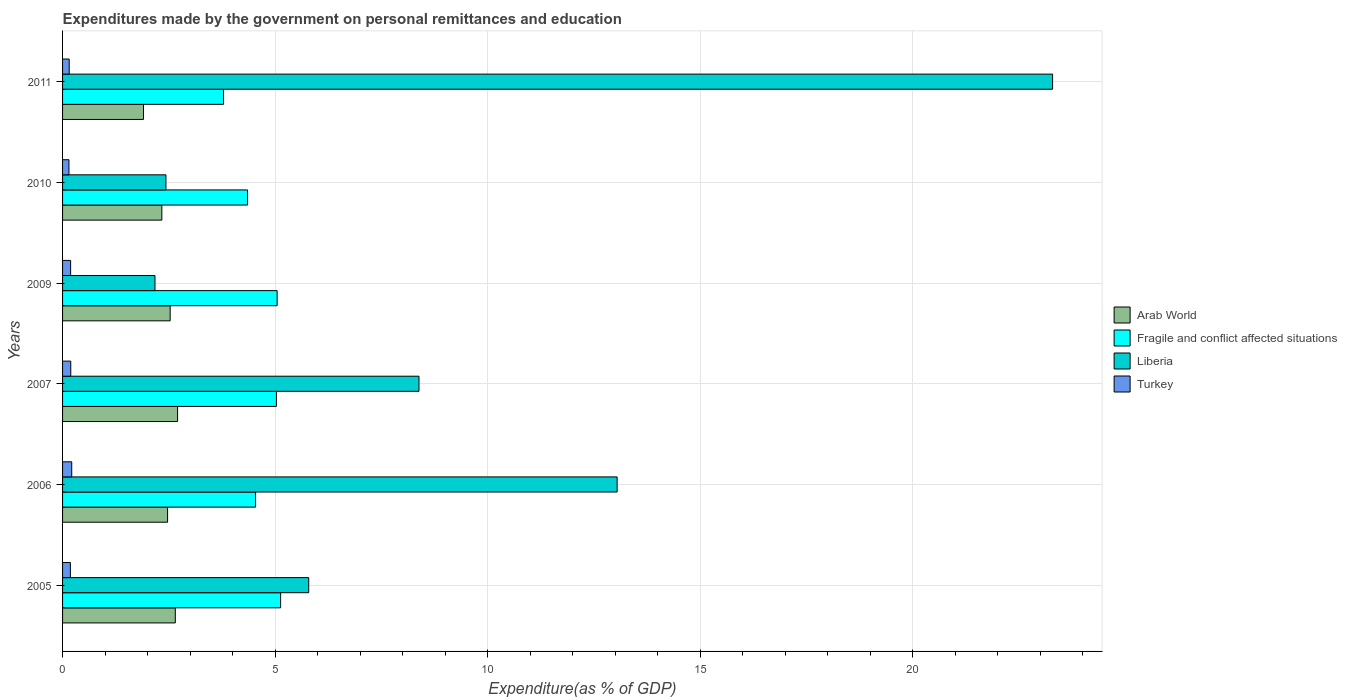How many different coloured bars are there?
Your answer should be compact. 4. How many groups of bars are there?
Your answer should be compact. 6. Are the number of bars on each tick of the Y-axis equal?
Offer a terse response. Yes. What is the expenditures made by the government on personal remittances and education in Fragile and conflict affected situations in 2010?
Your answer should be very brief. 4.35. Across all years, what is the maximum expenditures made by the government on personal remittances and education in Arab World?
Ensure brevity in your answer.  2.71. Across all years, what is the minimum expenditures made by the government on personal remittances and education in Fragile and conflict affected situations?
Offer a terse response. 3.79. In which year was the expenditures made by the government on personal remittances and education in Fragile and conflict affected situations minimum?
Keep it short and to the point. 2011. What is the total expenditures made by the government on personal remittances and education in Fragile and conflict affected situations in the graph?
Give a very brief answer. 27.89. What is the difference between the expenditures made by the government on personal remittances and education in Turkey in 2005 and that in 2009?
Provide a succinct answer. -0.01. What is the difference between the expenditures made by the government on personal remittances and education in Liberia in 2011 and the expenditures made by the government on personal remittances and education in Turkey in 2007?
Your answer should be compact. 23.1. What is the average expenditures made by the government on personal remittances and education in Fragile and conflict affected situations per year?
Provide a short and direct response. 4.65. In the year 2010, what is the difference between the expenditures made by the government on personal remittances and education in Arab World and expenditures made by the government on personal remittances and education in Fragile and conflict affected situations?
Provide a succinct answer. -2.02. In how many years, is the expenditures made by the government on personal remittances and education in Arab World greater than 6 %?
Your answer should be very brief. 0. What is the ratio of the expenditures made by the government on personal remittances and education in Liberia in 2006 to that in 2009?
Your answer should be very brief. 6. Is the expenditures made by the government on personal remittances and education in Turkey in 2009 less than that in 2011?
Keep it short and to the point. No. Is the difference between the expenditures made by the government on personal remittances and education in Arab World in 2006 and 2007 greater than the difference between the expenditures made by the government on personal remittances and education in Fragile and conflict affected situations in 2006 and 2007?
Your response must be concise. Yes. What is the difference between the highest and the second highest expenditures made by the government on personal remittances and education in Fragile and conflict affected situations?
Give a very brief answer. 0.08. What is the difference between the highest and the lowest expenditures made by the government on personal remittances and education in Turkey?
Ensure brevity in your answer.  0.07. In how many years, is the expenditures made by the government on personal remittances and education in Arab World greater than the average expenditures made by the government on personal remittances and education in Arab World taken over all years?
Give a very brief answer. 4. What does the 1st bar from the top in 2010 represents?
Your answer should be very brief. Turkey. What does the 2nd bar from the bottom in 2011 represents?
Provide a short and direct response. Fragile and conflict affected situations. Are all the bars in the graph horizontal?
Your response must be concise. Yes. What is the difference between two consecutive major ticks on the X-axis?
Your answer should be very brief. 5. Does the graph contain any zero values?
Ensure brevity in your answer.  No. Where does the legend appear in the graph?
Give a very brief answer. Center right. How are the legend labels stacked?
Provide a succinct answer. Vertical. What is the title of the graph?
Give a very brief answer. Expenditures made by the government on personal remittances and education. Does "Comoros" appear as one of the legend labels in the graph?
Offer a terse response. No. What is the label or title of the X-axis?
Ensure brevity in your answer.  Expenditure(as % of GDP). What is the label or title of the Y-axis?
Provide a short and direct response. Years. What is the Expenditure(as % of GDP) of Arab World in 2005?
Ensure brevity in your answer.  2.65. What is the Expenditure(as % of GDP) in Fragile and conflict affected situations in 2005?
Keep it short and to the point. 5.13. What is the Expenditure(as % of GDP) of Liberia in 2005?
Your response must be concise. 5.79. What is the Expenditure(as % of GDP) of Turkey in 2005?
Give a very brief answer. 0.18. What is the Expenditure(as % of GDP) of Arab World in 2006?
Offer a very short reply. 2.47. What is the Expenditure(as % of GDP) in Fragile and conflict affected situations in 2006?
Offer a terse response. 4.54. What is the Expenditure(as % of GDP) in Liberia in 2006?
Offer a very short reply. 13.05. What is the Expenditure(as % of GDP) of Turkey in 2006?
Offer a terse response. 0.22. What is the Expenditure(as % of GDP) in Arab World in 2007?
Ensure brevity in your answer.  2.71. What is the Expenditure(as % of GDP) of Fragile and conflict affected situations in 2007?
Your response must be concise. 5.03. What is the Expenditure(as % of GDP) in Liberia in 2007?
Give a very brief answer. 8.39. What is the Expenditure(as % of GDP) in Turkey in 2007?
Your response must be concise. 0.19. What is the Expenditure(as % of GDP) in Arab World in 2009?
Make the answer very short. 2.53. What is the Expenditure(as % of GDP) in Fragile and conflict affected situations in 2009?
Provide a succinct answer. 5.05. What is the Expenditure(as % of GDP) of Liberia in 2009?
Offer a very short reply. 2.17. What is the Expenditure(as % of GDP) of Turkey in 2009?
Ensure brevity in your answer.  0.19. What is the Expenditure(as % of GDP) of Arab World in 2010?
Give a very brief answer. 2.34. What is the Expenditure(as % of GDP) of Fragile and conflict affected situations in 2010?
Ensure brevity in your answer.  4.35. What is the Expenditure(as % of GDP) of Liberia in 2010?
Offer a terse response. 2.43. What is the Expenditure(as % of GDP) in Turkey in 2010?
Offer a terse response. 0.15. What is the Expenditure(as % of GDP) in Arab World in 2011?
Offer a very short reply. 1.9. What is the Expenditure(as % of GDP) of Fragile and conflict affected situations in 2011?
Provide a short and direct response. 3.79. What is the Expenditure(as % of GDP) of Liberia in 2011?
Give a very brief answer. 23.29. What is the Expenditure(as % of GDP) of Turkey in 2011?
Offer a terse response. 0.16. Across all years, what is the maximum Expenditure(as % of GDP) in Arab World?
Your answer should be compact. 2.71. Across all years, what is the maximum Expenditure(as % of GDP) of Fragile and conflict affected situations?
Your response must be concise. 5.13. Across all years, what is the maximum Expenditure(as % of GDP) in Liberia?
Offer a terse response. 23.29. Across all years, what is the maximum Expenditure(as % of GDP) of Turkey?
Offer a very short reply. 0.22. Across all years, what is the minimum Expenditure(as % of GDP) of Arab World?
Provide a succinct answer. 1.9. Across all years, what is the minimum Expenditure(as % of GDP) in Fragile and conflict affected situations?
Make the answer very short. 3.79. Across all years, what is the minimum Expenditure(as % of GDP) in Liberia?
Ensure brevity in your answer.  2.17. Across all years, what is the minimum Expenditure(as % of GDP) of Turkey?
Provide a succinct answer. 0.15. What is the total Expenditure(as % of GDP) in Arab World in the graph?
Keep it short and to the point. 14.6. What is the total Expenditure(as % of GDP) in Fragile and conflict affected situations in the graph?
Provide a short and direct response. 27.89. What is the total Expenditure(as % of GDP) of Liberia in the graph?
Offer a very short reply. 55.13. What is the total Expenditure(as % of GDP) of Turkey in the graph?
Your answer should be very brief. 1.09. What is the difference between the Expenditure(as % of GDP) of Arab World in 2005 and that in 2006?
Ensure brevity in your answer.  0.18. What is the difference between the Expenditure(as % of GDP) in Fragile and conflict affected situations in 2005 and that in 2006?
Make the answer very short. 0.59. What is the difference between the Expenditure(as % of GDP) in Liberia in 2005 and that in 2006?
Offer a very short reply. -7.26. What is the difference between the Expenditure(as % of GDP) in Turkey in 2005 and that in 2006?
Your response must be concise. -0.03. What is the difference between the Expenditure(as % of GDP) of Arab World in 2005 and that in 2007?
Make the answer very short. -0.05. What is the difference between the Expenditure(as % of GDP) in Fragile and conflict affected situations in 2005 and that in 2007?
Offer a terse response. 0.1. What is the difference between the Expenditure(as % of GDP) of Liberia in 2005 and that in 2007?
Provide a short and direct response. -2.59. What is the difference between the Expenditure(as % of GDP) of Turkey in 2005 and that in 2007?
Make the answer very short. -0.01. What is the difference between the Expenditure(as % of GDP) of Arab World in 2005 and that in 2009?
Ensure brevity in your answer.  0.12. What is the difference between the Expenditure(as % of GDP) of Fragile and conflict affected situations in 2005 and that in 2009?
Make the answer very short. 0.08. What is the difference between the Expenditure(as % of GDP) of Liberia in 2005 and that in 2009?
Ensure brevity in your answer.  3.62. What is the difference between the Expenditure(as % of GDP) of Turkey in 2005 and that in 2009?
Your answer should be very brief. -0.01. What is the difference between the Expenditure(as % of GDP) in Arab World in 2005 and that in 2010?
Ensure brevity in your answer.  0.32. What is the difference between the Expenditure(as % of GDP) in Fragile and conflict affected situations in 2005 and that in 2010?
Your answer should be compact. 0.78. What is the difference between the Expenditure(as % of GDP) of Liberia in 2005 and that in 2010?
Offer a terse response. 3.36. What is the difference between the Expenditure(as % of GDP) of Turkey in 2005 and that in 2010?
Your response must be concise. 0.03. What is the difference between the Expenditure(as % of GDP) of Arab World in 2005 and that in 2011?
Your answer should be very brief. 0.75. What is the difference between the Expenditure(as % of GDP) of Fragile and conflict affected situations in 2005 and that in 2011?
Your answer should be very brief. 1.34. What is the difference between the Expenditure(as % of GDP) of Liberia in 2005 and that in 2011?
Your answer should be compact. -17.5. What is the difference between the Expenditure(as % of GDP) in Turkey in 2005 and that in 2011?
Provide a short and direct response. 0.03. What is the difference between the Expenditure(as % of GDP) in Arab World in 2006 and that in 2007?
Ensure brevity in your answer.  -0.24. What is the difference between the Expenditure(as % of GDP) in Fragile and conflict affected situations in 2006 and that in 2007?
Offer a terse response. -0.49. What is the difference between the Expenditure(as % of GDP) in Liberia in 2006 and that in 2007?
Your answer should be compact. 4.66. What is the difference between the Expenditure(as % of GDP) of Turkey in 2006 and that in 2007?
Provide a succinct answer. 0.02. What is the difference between the Expenditure(as % of GDP) of Arab World in 2006 and that in 2009?
Offer a terse response. -0.06. What is the difference between the Expenditure(as % of GDP) in Fragile and conflict affected situations in 2006 and that in 2009?
Provide a succinct answer. -0.51. What is the difference between the Expenditure(as % of GDP) of Liberia in 2006 and that in 2009?
Keep it short and to the point. 10.87. What is the difference between the Expenditure(as % of GDP) of Turkey in 2006 and that in 2009?
Make the answer very short. 0.03. What is the difference between the Expenditure(as % of GDP) of Arab World in 2006 and that in 2010?
Provide a succinct answer. 0.14. What is the difference between the Expenditure(as % of GDP) in Fragile and conflict affected situations in 2006 and that in 2010?
Your answer should be very brief. 0.19. What is the difference between the Expenditure(as % of GDP) of Liberia in 2006 and that in 2010?
Your answer should be very brief. 10.62. What is the difference between the Expenditure(as % of GDP) of Turkey in 2006 and that in 2010?
Your answer should be compact. 0.07. What is the difference between the Expenditure(as % of GDP) of Arab World in 2006 and that in 2011?
Keep it short and to the point. 0.57. What is the difference between the Expenditure(as % of GDP) of Fragile and conflict affected situations in 2006 and that in 2011?
Your answer should be compact. 0.76. What is the difference between the Expenditure(as % of GDP) in Liberia in 2006 and that in 2011?
Provide a short and direct response. -10.25. What is the difference between the Expenditure(as % of GDP) of Turkey in 2006 and that in 2011?
Your response must be concise. 0.06. What is the difference between the Expenditure(as % of GDP) in Arab World in 2007 and that in 2009?
Your answer should be very brief. 0.17. What is the difference between the Expenditure(as % of GDP) of Fragile and conflict affected situations in 2007 and that in 2009?
Keep it short and to the point. -0.02. What is the difference between the Expenditure(as % of GDP) in Liberia in 2007 and that in 2009?
Your response must be concise. 6.21. What is the difference between the Expenditure(as % of GDP) in Turkey in 2007 and that in 2009?
Give a very brief answer. 0. What is the difference between the Expenditure(as % of GDP) in Arab World in 2007 and that in 2010?
Your answer should be compact. 0.37. What is the difference between the Expenditure(as % of GDP) of Fragile and conflict affected situations in 2007 and that in 2010?
Offer a terse response. 0.68. What is the difference between the Expenditure(as % of GDP) in Liberia in 2007 and that in 2010?
Make the answer very short. 5.95. What is the difference between the Expenditure(as % of GDP) in Turkey in 2007 and that in 2010?
Offer a terse response. 0.04. What is the difference between the Expenditure(as % of GDP) of Arab World in 2007 and that in 2011?
Offer a very short reply. 0.8. What is the difference between the Expenditure(as % of GDP) of Fragile and conflict affected situations in 2007 and that in 2011?
Keep it short and to the point. 1.24. What is the difference between the Expenditure(as % of GDP) in Liberia in 2007 and that in 2011?
Keep it short and to the point. -14.91. What is the difference between the Expenditure(as % of GDP) in Turkey in 2007 and that in 2011?
Your answer should be compact. 0.04. What is the difference between the Expenditure(as % of GDP) of Arab World in 2009 and that in 2010?
Make the answer very short. 0.2. What is the difference between the Expenditure(as % of GDP) of Fragile and conflict affected situations in 2009 and that in 2010?
Make the answer very short. 0.7. What is the difference between the Expenditure(as % of GDP) of Liberia in 2009 and that in 2010?
Your response must be concise. -0.26. What is the difference between the Expenditure(as % of GDP) of Turkey in 2009 and that in 2010?
Your response must be concise. 0.04. What is the difference between the Expenditure(as % of GDP) of Arab World in 2009 and that in 2011?
Provide a succinct answer. 0.63. What is the difference between the Expenditure(as % of GDP) in Fragile and conflict affected situations in 2009 and that in 2011?
Provide a succinct answer. 1.26. What is the difference between the Expenditure(as % of GDP) of Liberia in 2009 and that in 2011?
Your response must be concise. -21.12. What is the difference between the Expenditure(as % of GDP) in Turkey in 2009 and that in 2011?
Your answer should be very brief. 0.03. What is the difference between the Expenditure(as % of GDP) of Arab World in 2010 and that in 2011?
Provide a succinct answer. 0.43. What is the difference between the Expenditure(as % of GDP) of Fragile and conflict affected situations in 2010 and that in 2011?
Your answer should be very brief. 0.57. What is the difference between the Expenditure(as % of GDP) of Liberia in 2010 and that in 2011?
Give a very brief answer. -20.86. What is the difference between the Expenditure(as % of GDP) in Turkey in 2010 and that in 2011?
Offer a very short reply. -0.01. What is the difference between the Expenditure(as % of GDP) in Arab World in 2005 and the Expenditure(as % of GDP) in Fragile and conflict affected situations in 2006?
Your answer should be compact. -1.89. What is the difference between the Expenditure(as % of GDP) in Arab World in 2005 and the Expenditure(as % of GDP) in Liberia in 2006?
Give a very brief answer. -10.4. What is the difference between the Expenditure(as % of GDP) in Arab World in 2005 and the Expenditure(as % of GDP) in Turkey in 2006?
Ensure brevity in your answer.  2.44. What is the difference between the Expenditure(as % of GDP) of Fragile and conflict affected situations in 2005 and the Expenditure(as % of GDP) of Liberia in 2006?
Your answer should be very brief. -7.92. What is the difference between the Expenditure(as % of GDP) in Fragile and conflict affected situations in 2005 and the Expenditure(as % of GDP) in Turkey in 2006?
Your response must be concise. 4.91. What is the difference between the Expenditure(as % of GDP) of Liberia in 2005 and the Expenditure(as % of GDP) of Turkey in 2006?
Make the answer very short. 5.58. What is the difference between the Expenditure(as % of GDP) in Arab World in 2005 and the Expenditure(as % of GDP) in Fragile and conflict affected situations in 2007?
Ensure brevity in your answer.  -2.38. What is the difference between the Expenditure(as % of GDP) in Arab World in 2005 and the Expenditure(as % of GDP) in Liberia in 2007?
Your answer should be compact. -5.73. What is the difference between the Expenditure(as % of GDP) of Arab World in 2005 and the Expenditure(as % of GDP) of Turkey in 2007?
Offer a terse response. 2.46. What is the difference between the Expenditure(as % of GDP) in Fragile and conflict affected situations in 2005 and the Expenditure(as % of GDP) in Liberia in 2007?
Provide a succinct answer. -3.26. What is the difference between the Expenditure(as % of GDP) in Fragile and conflict affected situations in 2005 and the Expenditure(as % of GDP) in Turkey in 2007?
Your answer should be very brief. 4.94. What is the difference between the Expenditure(as % of GDP) of Liberia in 2005 and the Expenditure(as % of GDP) of Turkey in 2007?
Keep it short and to the point. 5.6. What is the difference between the Expenditure(as % of GDP) in Arab World in 2005 and the Expenditure(as % of GDP) in Fragile and conflict affected situations in 2009?
Keep it short and to the point. -2.4. What is the difference between the Expenditure(as % of GDP) in Arab World in 2005 and the Expenditure(as % of GDP) in Liberia in 2009?
Ensure brevity in your answer.  0.48. What is the difference between the Expenditure(as % of GDP) of Arab World in 2005 and the Expenditure(as % of GDP) of Turkey in 2009?
Offer a terse response. 2.46. What is the difference between the Expenditure(as % of GDP) in Fragile and conflict affected situations in 2005 and the Expenditure(as % of GDP) in Liberia in 2009?
Ensure brevity in your answer.  2.96. What is the difference between the Expenditure(as % of GDP) of Fragile and conflict affected situations in 2005 and the Expenditure(as % of GDP) of Turkey in 2009?
Offer a terse response. 4.94. What is the difference between the Expenditure(as % of GDP) in Liberia in 2005 and the Expenditure(as % of GDP) in Turkey in 2009?
Provide a short and direct response. 5.6. What is the difference between the Expenditure(as % of GDP) of Arab World in 2005 and the Expenditure(as % of GDP) of Fragile and conflict affected situations in 2010?
Give a very brief answer. -1.7. What is the difference between the Expenditure(as % of GDP) in Arab World in 2005 and the Expenditure(as % of GDP) in Liberia in 2010?
Your answer should be compact. 0.22. What is the difference between the Expenditure(as % of GDP) in Arab World in 2005 and the Expenditure(as % of GDP) in Turkey in 2010?
Your answer should be very brief. 2.5. What is the difference between the Expenditure(as % of GDP) in Fragile and conflict affected situations in 2005 and the Expenditure(as % of GDP) in Liberia in 2010?
Make the answer very short. 2.7. What is the difference between the Expenditure(as % of GDP) of Fragile and conflict affected situations in 2005 and the Expenditure(as % of GDP) of Turkey in 2010?
Your response must be concise. 4.98. What is the difference between the Expenditure(as % of GDP) in Liberia in 2005 and the Expenditure(as % of GDP) in Turkey in 2010?
Give a very brief answer. 5.64. What is the difference between the Expenditure(as % of GDP) in Arab World in 2005 and the Expenditure(as % of GDP) in Fragile and conflict affected situations in 2011?
Offer a terse response. -1.13. What is the difference between the Expenditure(as % of GDP) of Arab World in 2005 and the Expenditure(as % of GDP) of Liberia in 2011?
Provide a succinct answer. -20.64. What is the difference between the Expenditure(as % of GDP) in Arab World in 2005 and the Expenditure(as % of GDP) in Turkey in 2011?
Your answer should be compact. 2.5. What is the difference between the Expenditure(as % of GDP) in Fragile and conflict affected situations in 2005 and the Expenditure(as % of GDP) in Liberia in 2011?
Your answer should be very brief. -18.16. What is the difference between the Expenditure(as % of GDP) in Fragile and conflict affected situations in 2005 and the Expenditure(as % of GDP) in Turkey in 2011?
Your answer should be very brief. 4.97. What is the difference between the Expenditure(as % of GDP) of Liberia in 2005 and the Expenditure(as % of GDP) of Turkey in 2011?
Offer a very short reply. 5.64. What is the difference between the Expenditure(as % of GDP) in Arab World in 2006 and the Expenditure(as % of GDP) in Fragile and conflict affected situations in 2007?
Make the answer very short. -2.56. What is the difference between the Expenditure(as % of GDP) of Arab World in 2006 and the Expenditure(as % of GDP) of Liberia in 2007?
Provide a short and direct response. -5.92. What is the difference between the Expenditure(as % of GDP) of Arab World in 2006 and the Expenditure(as % of GDP) of Turkey in 2007?
Ensure brevity in your answer.  2.28. What is the difference between the Expenditure(as % of GDP) in Fragile and conflict affected situations in 2006 and the Expenditure(as % of GDP) in Liberia in 2007?
Keep it short and to the point. -3.84. What is the difference between the Expenditure(as % of GDP) of Fragile and conflict affected situations in 2006 and the Expenditure(as % of GDP) of Turkey in 2007?
Your response must be concise. 4.35. What is the difference between the Expenditure(as % of GDP) in Liberia in 2006 and the Expenditure(as % of GDP) in Turkey in 2007?
Offer a very short reply. 12.86. What is the difference between the Expenditure(as % of GDP) in Arab World in 2006 and the Expenditure(as % of GDP) in Fragile and conflict affected situations in 2009?
Provide a short and direct response. -2.58. What is the difference between the Expenditure(as % of GDP) in Arab World in 2006 and the Expenditure(as % of GDP) in Liberia in 2009?
Make the answer very short. 0.3. What is the difference between the Expenditure(as % of GDP) of Arab World in 2006 and the Expenditure(as % of GDP) of Turkey in 2009?
Your answer should be very brief. 2.28. What is the difference between the Expenditure(as % of GDP) of Fragile and conflict affected situations in 2006 and the Expenditure(as % of GDP) of Liberia in 2009?
Your answer should be very brief. 2.37. What is the difference between the Expenditure(as % of GDP) in Fragile and conflict affected situations in 2006 and the Expenditure(as % of GDP) in Turkey in 2009?
Your answer should be very brief. 4.35. What is the difference between the Expenditure(as % of GDP) in Liberia in 2006 and the Expenditure(as % of GDP) in Turkey in 2009?
Your answer should be compact. 12.86. What is the difference between the Expenditure(as % of GDP) in Arab World in 2006 and the Expenditure(as % of GDP) in Fragile and conflict affected situations in 2010?
Provide a succinct answer. -1.88. What is the difference between the Expenditure(as % of GDP) of Arab World in 2006 and the Expenditure(as % of GDP) of Liberia in 2010?
Provide a succinct answer. 0.04. What is the difference between the Expenditure(as % of GDP) in Arab World in 2006 and the Expenditure(as % of GDP) in Turkey in 2010?
Provide a succinct answer. 2.32. What is the difference between the Expenditure(as % of GDP) in Fragile and conflict affected situations in 2006 and the Expenditure(as % of GDP) in Liberia in 2010?
Keep it short and to the point. 2.11. What is the difference between the Expenditure(as % of GDP) in Fragile and conflict affected situations in 2006 and the Expenditure(as % of GDP) in Turkey in 2010?
Your response must be concise. 4.39. What is the difference between the Expenditure(as % of GDP) in Liberia in 2006 and the Expenditure(as % of GDP) in Turkey in 2010?
Offer a terse response. 12.9. What is the difference between the Expenditure(as % of GDP) of Arab World in 2006 and the Expenditure(as % of GDP) of Fragile and conflict affected situations in 2011?
Offer a terse response. -1.32. What is the difference between the Expenditure(as % of GDP) in Arab World in 2006 and the Expenditure(as % of GDP) in Liberia in 2011?
Keep it short and to the point. -20.82. What is the difference between the Expenditure(as % of GDP) of Arab World in 2006 and the Expenditure(as % of GDP) of Turkey in 2011?
Your answer should be compact. 2.31. What is the difference between the Expenditure(as % of GDP) in Fragile and conflict affected situations in 2006 and the Expenditure(as % of GDP) in Liberia in 2011?
Keep it short and to the point. -18.75. What is the difference between the Expenditure(as % of GDP) of Fragile and conflict affected situations in 2006 and the Expenditure(as % of GDP) of Turkey in 2011?
Keep it short and to the point. 4.39. What is the difference between the Expenditure(as % of GDP) in Liberia in 2006 and the Expenditure(as % of GDP) in Turkey in 2011?
Your answer should be very brief. 12.89. What is the difference between the Expenditure(as % of GDP) of Arab World in 2007 and the Expenditure(as % of GDP) of Fragile and conflict affected situations in 2009?
Keep it short and to the point. -2.34. What is the difference between the Expenditure(as % of GDP) of Arab World in 2007 and the Expenditure(as % of GDP) of Liberia in 2009?
Provide a short and direct response. 0.53. What is the difference between the Expenditure(as % of GDP) of Arab World in 2007 and the Expenditure(as % of GDP) of Turkey in 2009?
Provide a succinct answer. 2.52. What is the difference between the Expenditure(as % of GDP) in Fragile and conflict affected situations in 2007 and the Expenditure(as % of GDP) in Liberia in 2009?
Provide a succinct answer. 2.86. What is the difference between the Expenditure(as % of GDP) in Fragile and conflict affected situations in 2007 and the Expenditure(as % of GDP) in Turkey in 2009?
Give a very brief answer. 4.84. What is the difference between the Expenditure(as % of GDP) of Liberia in 2007 and the Expenditure(as % of GDP) of Turkey in 2009?
Provide a succinct answer. 8.2. What is the difference between the Expenditure(as % of GDP) in Arab World in 2007 and the Expenditure(as % of GDP) in Fragile and conflict affected situations in 2010?
Your answer should be very brief. -1.65. What is the difference between the Expenditure(as % of GDP) in Arab World in 2007 and the Expenditure(as % of GDP) in Liberia in 2010?
Provide a short and direct response. 0.27. What is the difference between the Expenditure(as % of GDP) in Arab World in 2007 and the Expenditure(as % of GDP) in Turkey in 2010?
Make the answer very short. 2.56. What is the difference between the Expenditure(as % of GDP) in Fragile and conflict affected situations in 2007 and the Expenditure(as % of GDP) in Liberia in 2010?
Your response must be concise. 2.6. What is the difference between the Expenditure(as % of GDP) of Fragile and conflict affected situations in 2007 and the Expenditure(as % of GDP) of Turkey in 2010?
Make the answer very short. 4.88. What is the difference between the Expenditure(as % of GDP) in Liberia in 2007 and the Expenditure(as % of GDP) in Turkey in 2010?
Your response must be concise. 8.24. What is the difference between the Expenditure(as % of GDP) in Arab World in 2007 and the Expenditure(as % of GDP) in Fragile and conflict affected situations in 2011?
Give a very brief answer. -1.08. What is the difference between the Expenditure(as % of GDP) of Arab World in 2007 and the Expenditure(as % of GDP) of Liberia in 2011?
Offer a very short reply. -20.59. What is the difference between the Expenditure(as % of GDP) in Arab World in 2007 and the Expenditure(as % of GDP) in Turkey in 2011?
Provide a short and direct response. 2.55. What is the difference between the Expenditure(as % of GDP) of Fragile and conflict affected situations in 2007 and the Expenditure(as % of GDP) of Liberia in 2011?
Give a very brief answer. -18.26. What is the difference between the Expenditure(as % of GDP) of Fragile and conflict affected situations in 2007 and the Expenditure(as % of GDP) of Turkey in 2011?
Offer a terse response. 4.88. What is the difference between the Expenditure(as % of GDP) of Liberia in 2007 and the Expenditure(as % of GDP) of Turkey in 2011?
Your answer should be very brief. 8.23. What is the difference between the Expenditure(as % of GDP) in Arab World in 2009 and the Expenditure(as % of GDP) in Fragile and conflict affected situations in 2010?
Make the answer very short. -1.82. What is the difference between the Expenditure(as % of GDP) in Arab World in 2009 and the Expenditure(as % of GDP) in Liberia in 2010?
Ensure brevity in your answer.  0.1. What is the difference between the Expenditure(as % of GDP) of Arab World in 2009 and the Expenditure(as % of GDP) of Turkey in 2010?
Make the answer very short. 2.38. What is the difference between the Expenditure(as % of GDP) in Fragile and conflict affected situations in 2009 and the Expenditure(as % of GDP) in Liberia in 2010?
Your answer should be very brief. 2.62. What is the difference between the Expenditure(as % of GDP) of Fragile and conflict affected situations in 2009 and the Expenditure(as % of GDP) of Turkey in 2010?
Make the answer very short. 4.9. What is the difference between the Expenditure(as % of GDP) of Liberia in 2009 and the Expenditure(as % of GDP) of Turkey in 2010?
Give a very brief answer. 2.02. What is the difference between the Expenditure(as % of GDP) of Arab World in 2009 and the Expenditure(as % of GDP) of Fragile and conflict affected situations in 2011?
Offer a terse response. -1.26. What is the difference between the Expenditure(as % of GDP) in Arab World in 2009 and the Expenditure(as % of GDP) in Liberia in 2011?
Your response must be concise. -20.76. What is the difference between the Expenditure(as % of GDP) of Arab World in 2009 and the Expenditure(as % of GDP) of Turkey in 2011?
Your answer should be very brief. 2.38. What is the difference between the Expenditure(as % of GDP) of Fragile and conflict affected situations in 2009 and the Expenditure(as % of GDP) of Liberia in 2011?
Your response must be concise. -18.25. What is the difference between the Expenditure(as % of GDP) in Fragile and conflict affected situations in 2009 and the Expenditure(as % of GDP) in Turkey in 2011?
Provide a short and direct response. 4.89. What is the difference between the Expenditure(as % of GDP) in Liberia in 2009 and the Expenditure(as % of GDP) in Turkey in 2011?
Provide a succinct answer. 2.02. What is the difference between the Expenditure(as % of GDP) of Arab World in 2010 and the Expenditure(as % of GDP) of Fragile and conflict affected situations in 2011?
Keep it short and to the point. -1.45. What is the difference between the Expenditure(as % of GDP) in Arab World in 2010 and the Expenditure(as % of GDP) in Liberia in 2011?
Offer a very short reply. -20.96. What is the difference between the Expenditure(as % of GDP) in Arab World in 2010 and the Expenditure(as % of GDP) in Turkey in 2011?
Your answer should be very brief. 2.18. What is the difference between the Expenditure(as % of GDP) of Fragile and conflict affected situations in 2010 and the Expenditure(as % of GDP) of Liberia in 2011?
Provide a short and direct response. -18.94. What is the difference between the Expenditure(as % of GDP) in Fragile and conflict affected situations in 2010 and the Expenditure(as % of GDP) in Turkey in 2011?
Offer a terse response. 4.2. What is the difference between the Expenditure(as % of GDP) in Liberia in 2010 and the Expenditure(as % of GDP) in Turkey in 2011?
Make the answer very short. 2.28. What is the average Expenditure(as % of GDP) of Arab World per year?
Your response must be concise. 2.43. What is the average Expenditure(as % of GDP) in Fragile and conflict affected situations per year?
Offer a terse response. 4.65. What is the average Expenditure(as % of GDP) in Liberia per year?
Offer a terse response. 9.19. What is the average Expenditure(as % of GDP) of Turkey per year?
Your response must be concise. 0.18. In the year 2005, what is the difference between the Expenditure(as % of GDP) in Arab World and Expenditure(as % of GDP) in Fragile and conflict affected situations?
Your answer should be very brief. -2.48. In the year 2005, what is the difference between the Expenditure(as % of GDP) in Arab World and Expenditure(as % of GDP) in Liberia?
Offer a very short reply. -3.14. In the year 2005, what is the difference between the Expenditure(as % of GDP) in Arab World and Expenditure(as % of GDP) in Turkey?
Your answer should be very brief. 2.47. In the year 2005, what is the difference between the Expenditure(as % of GDP) in Fragile and conflict affected situations and Expenditure(as % of GDP) in Liberia?
Provide a short and direct response. -0.66. In the year 2005, what is the difference between the Expenditure(as % of GDP) of Fragile and conflict affected situations and Expenditure(as % of GDP) of Turkey?
Keep it short and to the point. 4.95. In the year 2005, what is the difference between the Expenditure(as % of GDP) of Liberia and Expenditure(as % of GDP) of Turkey?
Ensure brevity in your answer.  5.61. In the year 2006, what is the difference between the Expenditure(as % of GDP) in Arab World and Expenditure(as % of GDP) in Fragile and conflict affected situations?
Ensure brevity in your answer.  -2.07. In the year 2006, what is the difference between the Expenditure(as % of GDP) of Arab World and Expenditure(as % of GDP) of Liberia?
Your response must be concise. -10.58. In the year 2006, what is the difference between the Expenditure(as % of GDP) of Arab World and Expenditure(as % of GDP) of Turkey?
Make the answer very short. 2.25. In the year 2006, what is the difference between the Expenditure(as % of GDP) of Fragile and conflict affected situations and Expenditure(as % of GDP) of Liberia?
Keep it short and to the point. -8.51. In the year 2006, what is the difference between the Expenditure(as % of GDP) of Fragile and conflict affected situations and Expenditure(as % of GDP) of Turkey?
Your answer should be very brief. 4.33. In the year 2006, what is the difference between the Expenditure(as % of GDP) in Liberia and Expenditure(as % of GDP) in Turkey?
Offer a terse response. 12.83. In the year 2007, what is the difference between the Expenditure(as % of GDP) in Arab World and Expenditure(as % of GDP) in Fragile and conflict affected situations?
Make the answer very short. -2.33. In the year 2007, what is the difference between the Expenditure(as % of GDP) of Arab World and Expenditure(as % of GDP) of Liberia?
Keep it short and to the point. -5.68. In the year 2007, what is the difference between the Expenditure(as % of GDP) in Arab World and Expenditure(as % of GDP) in Turkey?
Offer a terse response. 2.51. In the year 2007, what is the difference between the Expenditure(as % of GDP) of Fragile and conflict affected situations and Expenditure(as % of GDP) of Liberia?
Provide a short and direct response. -3.35. In the year 2007, what is the difference between the Expenditure(as % of GDP) of Fragile and conflict affected situations and Expenditure(as % of GDP) of Turkey?
Give a very brief answer. 4.84. In the year 2007, what is the difference between the Expenditure(as % of GDP) in Liberia and Expenditure(as % of GDP) in Turkey?
Make the answer very short. 8.19. In the year 2009, what is the difference between the Expenditure(as % of GDP) in Arab World and Expenditure(as % of GDP) in Fragile and conflict affected situations?
Your answer should be compact. -2.52. In the year 2009, what is the difference between the Expenditure(as % of GDP) of Arab World and Expenditure(as % of GDP) of Liberia?
Your answer should be compact. 0.36. In the year 2009, what is the difference between the Expenditure(as % of GDP) of Arab World and Expenditure(as % of GDP) of Turkey?
Ensure brevity in your answer.  2.34. In the year 2009, what is the difference between the Expenditure(as % of GDP) of Fragile and conflict affected situations and Expenditure(as % of GDP) of Liberia?
Offer a terse response. 2.87. In the year 2009, what is the difference between the Expenditure(as % of GDP) of Fragile and conflict affected situations and Expenditure(as % of GDP) of Turkey?
Your answer should be compact. 4.86. In the year 2009, what is the difference between the Expenditure(as % of GDP) of Liberia and Expenditure(as % of GDP) of Turkey?
Keep it short and to the point. 1.98. In the year 2010, what is the difference between the Expenditure(as % of GDP) of Arab World and Expenditure(as % of GDP) of Fragile and conflict affected situations?
Your answer should be compact. -2.02. In the year 2010, what is the difference between the Expenditure(as % of GDP) in Arab World and Expenditure(as % of GDP) in Liberia?
Make the answer very short. -0.1. In the year 2010, what is the difference between the Expenditure(as % of GDP) in Arab World and Expenditure(as % of GDP) in Turkey?
Keep it short and to the point. 2.19. In the year 2010, what is the difference between the Expenditure(as % of GDP) of Fragile and conflict affected situations and Expenditure(as % of GDP) of Liberia?
Make the answer very short. 1.92. In the year 2010, what is the difference between the Expenditure(as % of GDP) of Fragile and conflict affected situations and Expenditure(as % of GDP) of Turkey?
Offer a very short reply. 4.2. In the year 2010, what is the difference between the Expenditure(as % of GDP) in Liberia and Expenditure(as % of GDP) in Turkey?
Your response must be concise. 2.28. In the year 2011, what is the difference between the Expenditure(as % of GDP) of Arab World and Expenditure(as % of GDP) of Fragile and conflict affected situations?
Offer a very short reply. -1.88. In the year 2011, what is the difference between the Expenditure(as % of GDP) of Arab World and Expenditure(as % of GDP) of Liberia?
Your answer should be compact. -21.39. In the year 2011, what is the difference between the Expenditure(as % of GDP) in Arab World and Expenditure(as % of GDP) in Turkey?
Keep it short and to the point. 1.75. In the year 2011, what is the difference between the Expenditure(as % of GDP) in Fragile and conflict affected situations and Expenditure(as % of GDP) in Liberia?
Keep it short and to the point. -19.51. In the year 2011, what is the difference between the Expenditure(as % of GDP) of Fragile and conflict affected situations and Expenditure(as % of GDP) of Turkey?
Provide a succinct answer. 3.63. In the year 2011, what is the difference between the Expenditure(as % of GDP) of Liberia and Expenditure(as % of GDP) of Turkey?
Your answer should be compact. 23.14. What is the ratio of the Expenditure(as % of GDP) in Arab World in 2005 to that in 2006?
Keep it short and to the point. 1.07. What is the ratio of the Expenditure(as % of GDP) of Fragile and conflict affected situations in 2005 to that in 2006?
Make the answer very short. 1.13. What is the ratio of the Expenditure(as % of GDP) of Liberia in 2005 to that in 2006?
Make the answer very short. 0.44. What is the ratio of the Expenditure(as % of GDP) in Turkey in 2005 to that in 2006?
Your answer should be very brief. 0.85. What is the ratio of the Expenditure(as % of GDP) of Arab World in 2005 to that in 2007?
Keep it short and to the point. 0.98. What is the ratio of the Expenditure(as % of GDP) in Fragile and conflict affected situations in 2005 to that in 2007?
Offer a terse response. 1.02. What is the ratio of the Expenditure(as % of GDP) of Liberia in 2005 to that in 2007?
Offer a terse response. 0.69. What is the ratio of the Expenditure(as % of GDP) of Turkey in 2005 to that in 2007?
Provide a short and direct response. 0.95. What is the ratio of the Expenditure(as % of GDP) of Arab World in 2005 to that in 2009?
Offer a terse response. 1.05. What is the ratio of the Expenditure(as % of GDP) of Fragile and conflict affected situations in 2005 to that in 2009?
Provide a short and direct response. 1.02. What is the ratio of the Expenditure(as % of GDP) of Liberia in 2005 to that in 2009?
Offer a terse response. 2.66. What is the ratio of the Expenditure(as % of GDP) in Turkey in 2005 to that in 2009?
Offer a terse response. 0.97. What is the ratio of the Expenditure(as % of GDP) of Arab World in 2005 to that in 2010?
Keep it short and to the point. 1.14. What is the ratio of the Expenditure(as % of GDP) of Fragile and conflict affected situations in 2005 to that in 2010?
Keep it short and to the point. 1.18. What is the ratio of the Expenditure(as % of GDP) of Liberia in 2005 to that in 2010?
Offer a terse response. 2.38. What is the ratio of the Expenditure(as % of GDP) in Turkey in 2005 to that in 2010?
Ensure brevity in your answer.  1.22. What is the ratio of the Expenditure(as % of GDP) of Arab World in 2005 to that in 2011?
Ensure brevity in your answer.  1.39. What is the ratio of the Expenditure(as % of GDP) in Fragile and conflict affected situations in 2005 to that in 2011?
Give a very brief answer. 1.35. What is the ratio of the Expenditure(as % of GDP) of Liberia in 2005 to that in 2011?
Ensure brevity in your answer.  0.25. What is the ratio of the Expenditure(as % of GDP) of Turkey in 2005 to that in 2011?
Keep it short and to the point. 1.18. What is the ratio of the Expenditure(as % of GDP) in Arab World in 2006 to that in 2007?
Your answer should be very brief. 0.91. What is the ratio of the Expenditure(as % of GDP) of Fragile and conflict affected situations in 2006 to that in 2007?
Your answer should be compact. 0.9. What is the ratio of the Expenditure(as % of GDP) in Liberia in 2006 to that in 2007?
Keep it short and to the point. 1.56. What is the ratio of the Expenditure(as % of GDP) of Turkey in 2006 to that in 2007?
Provide a succinct answer. 1.12. What is the ratio of the Expenditure(as % of GDP) of Arab World in 2006 to that in 2009?
Keep it short and to the point. 0.98. What is the ratio of the Expenditure(as % of GDP) in Fragile and conflict affected situations in 2006 to that in 2009?
Make the answer very short. 0.9. What is the ratio of the Expenditure(as % of GDP) in Liberia in 2006 to that in 2009?
Provide a short and direct response. 6. What is the ratio of the Expenditure(as % of GDP) in Turkey in 2006 to that in 2009?
Provide a short and direct response. 1.14. What is the ratio of the Expenditure(as % of GDP) of Arab World in 2006 to that in 2010?
Provide a succinct answer. 1.06. What is the ratio of the Expenditure(as % of GDP) of Fragile and conflict affected situations in 2006 to that in 2010?
Offer a terse response. 1.04. What is the ratio of the Expenditure(as % of GDP) in Liberia in 2006 to that in 2010?
Give a very brief answer. 5.36. What is the ratio of the Expenditure(as % of GDP) of Turkey in 2006 to that in 2010?
Keep it short and to the point. 1.43. What is the ratio of the Expenditure(as % of GDP) of Arab World in 2006 to that in 2011?
Ensure brevity in your answer.  1.3. What is the ratio of the Expenditure(as % of GDP) of Fragile and conflict affected situations in 2006 to that in 2011?
Make the answer very short. 1.2. What is the ratio of the Expenditure(as % of GDP) of Liberia in 2006 to that in 2011?
Provide a short and direct response. 0.56. What is the ratio of the Expenditure(as % of GDP) of Turkey in 2006 to that in 2011?
Your response must be concise. 1.38. What is the ratio of the Expenditure(as % of GDP) of Arab World in 2007 to that in 2009?
Your response must be concise. 1.07. What is the ratio of the Expenditure(as % of GDP) in Liberia in 2007 to that in 2009?
Offer a terse response. 3.86. What is the ratio of the Expenditure(as % of GDP) of Turkey in 2007 to that in 2009?
Your response must be concise. 1.02. What is the ratio of the Expenditure(as % of GDP) in Arab World in 2007 to that in 2010?
Offer a terse response. 1.16. What is the ratio of the Expenditure(as % of GDP) in Fragile and conflict affected situations in 2007 to that in 2010?
Provide a short and direct response. 1.16. What is the ratio of the Expenditure(as % of GDP) of Liberia in 2007 to that in 2010?
Your answer should be very brief. 3.45. What is the ratio of the Expenditure(as % of GDP) in Turkey in 2007 to that in 2010?
Give a very brief answer. 1.28. What is the ratio of the Expenditure(as % of GDP) in Arab World in 2007 to that in 2011?
Provide a succinct answer. 1.42. What is the ratio of the Expenditure(as % of GDP) in Fragile and conflict affected situations in 2007 to that in 2011?
Keep it short and to the point. 1.33. What is the ratio of the Expenditure(as % of GDP) in Liberia in 2007 to that in 2011?
Make the answer very short. 0.36. What is the ratio of the Expenditure(as % of GDP) in Turkey in 2007 to that in 2011?
Give a very brief answer. 1.23. What is the ratio of the Expenditure(as % of GDP) in Arab World in 2009 to that in 2010?
Your response must be concise. 1.08. What is the ratio of the Expenditure(as % of GDP) in Fragile and conflict affected situations in 2009 to that in 2010?
Give a very brief answer. 1.16. What is the ratio of the Expenditure(as % of GDP) of Liberia in 2009 to that in 2010?
Offer a very short reply. 0.89. What is the ratio of the Expenditure(as % of GDP) of Turkey in 2009 to that in 2010?
Offer a terse response. 1.26. What is the ratio of the Expenditure(as % of GDP) of Arab World in 2009 to that in 2011?
Keep it short and to the point. 1.33. What is the ratio of the Expenditure(as % of GDP) of Fragile and conflict affected situations in 2009 to that in 2011?
Your answer should be compact. 1.33. What is the ratio of the Expenditure(as % of GDP) in Liberia in 2009 to that in 2011?
Give a very brief answer. 0.09. What is the ratio of the Expenditure(as % of GDP) in Turkey in 2009 to that in 2011?
Provide a short and direct response. 1.21. What is the ratio of the Expenditure(as % of GDP) in Arab World in 2010 to that in 2011?
Keep it short and to the point. 1.23. What is the ratio of the Expenditure(as % of GDP) in Fragile and conflict affected situations in 2010 to that in 2011?
Offer a very short reply. 1.15. What is the ratio of the Expenditure(as % of GDP) in Liberia in 2010 to that in 2011?
Your answer should be very brief. 0.1. What is the ratio of the Expenditure(as % of GDP) in Turkey in 2010 to that in 2011?
Keep it short and to the point. 0.96. What is the difference between the highest and the second highest Expenditure(as % of GDP) in Arab World?
Give a very brief answer. 0.05. What is the difference between the highest and the second highest Expenditure(as % of GDP) of Fragile and conflict affected situations?
Make the answer very short. 0.08. What is the difference between the highest and the second highest Expenditure(as % of GDP) of Liberia?
Provide a succinct answer. 10.25. What is the difference between the highest and the second highest Expenditure(as % of GDP) of Turkey?
Offer a very short reply. 0.02. What is the difference between the highest and the lowest Expenditure(as % of GDP) of Arab World?
Give a very brief answer. 0.8. What is the difference between the highest and the lowest Expenditure(as % of GDP) in Fragile and conflict affected situations?
Provide a short and direct response. 1.34. What is the difference between the highest and the lowest Expenditure(as % of GDP) in Liberia?
Your answer should be compact. 21.12. What is the difference between the highest and the lowest Expenditure(as % of GDP) in Turkey?
Keep it short and to the point. 0.07. 